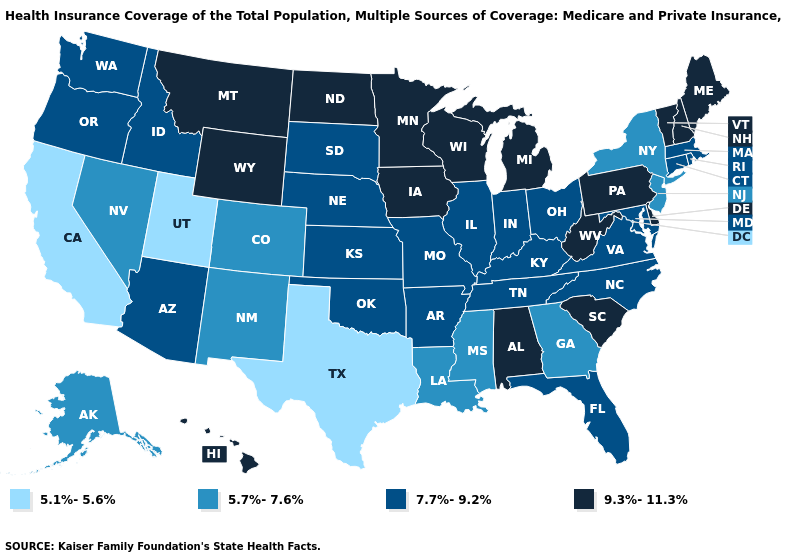What is the value of Kentucky?
Concise answer only. 7.7%-9.2%. What is the value of Oklahoma?
Write a very short answer. 7.7%-9.2%. Does Hawaii have the highest value in the West?
Write a very short answer. Yes. Which states hav the highest value in the Northeast?
Concise answer only. Maine, New Hampshire, Pennsylvania, Vermont. What is the highest value in the USA?
Be succinct. 9.3%-11.3%. Does Texas have a lower value than Iowa?
Keep it brief. Yes. What is the value of Alaska?
Quick response, please. 5.7%-7.6%. Name the states that have a value in the range 9.3%-11.3%?
Be succinct. Alabama, Delaware, Hawaii, Iowa, Maine, Michigan, Minnesota, Montana, New Hampshire, North Dakota, Pennsylvania, South Carolina, Vermont, West Virginia, Wisconsin, Wyoming. Name the states that have a value in the range 5.7%-7.6%?
Be succinct. Alaska, Colorado, Georgia, Louisiana, Mississippi, Nevada, New Jersey, New Mexico, New York. Among the states that border Oregon , does California have the highest value?
Write a very short answer. No. What is the highest value in states that border Massachusetts?
Answer briefly. 9.3%-11.3%. Name the states that have a value in the range 5.1%-5.6%?
Answer briefly. California, Texas, Utah. What is the highest value in the USA?
Be succinct. 9.3%-11.3%. Does the first symbol in the legend represent the smallest category?
Answer briefly. Yes. Is the legend a continuous bar?
Quick response, please. No. 